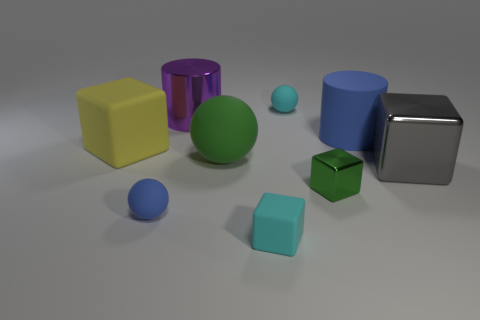Subtract all green metallic cubes. How many cubes are left? 3 Subtract all big rubber spheres. Subtract all big blue objects. How many objects are left? 7 Add 9 small metallic objects. How many small metallic objects are left? 10 Add 6 gray rubber balls. How many gray rubber balls exist? 6 Subtract all cyan balls. How many balls are left? 2 Subtract 1 green cubes. How many objects are left? 8 Subtract all cylinders. How many objects are left? 7 Subtract 2 spheres. How many spheres are left? 1 Subtract all brown cylinders. Subtract all purple cubes. How many cylinders are left? 2 Subtract all red cylinders. How many purple balls are left? 0 